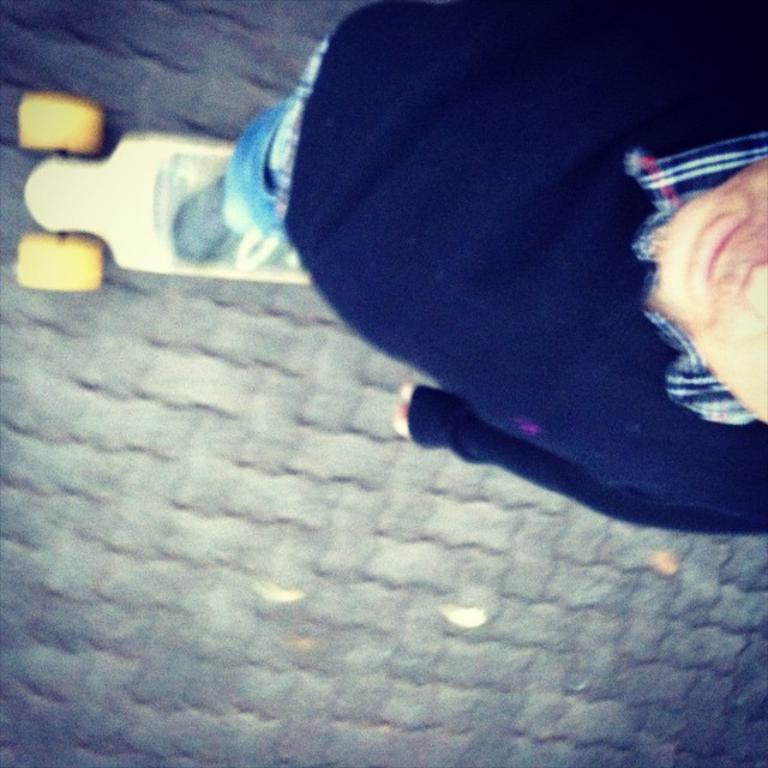Who is present in the image? There is a man in the image. What is the man wearing? The man is wearing a blue jacket and jeans. What activity is the man engaged in? The man is skating on the road. What type of brick is the man using to wash his clothes in the image? There is no brick or washing activity present in the image; the man is skating on the road. 